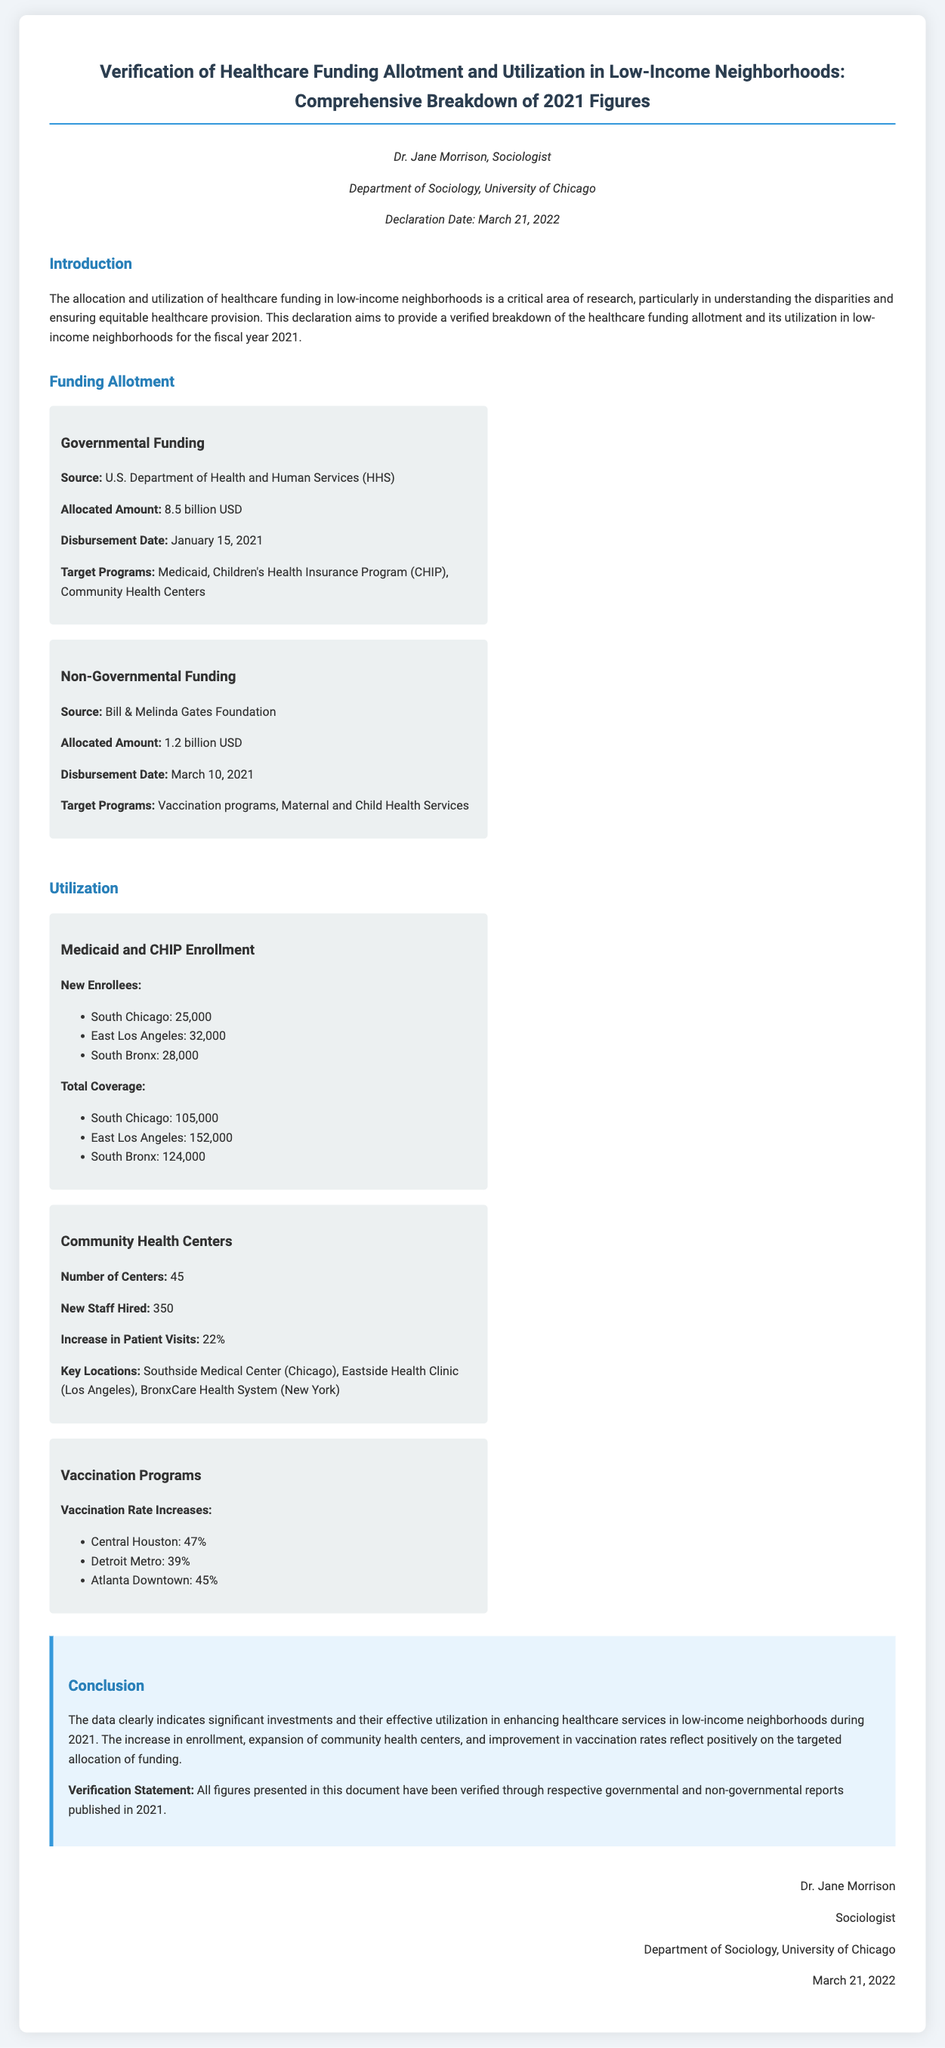What is the allocated amount for governmental funding? The document states the allocated amount for governmental funding, which is provided under the funding allotment section.
Answer: 8.5 billion USD Who is the author of the declaration? The document presents the author information at the beginning, allowing for easy retrieval of the author's identity.
Answer: Dr. Jane Morrison What date was the non-governmental funding disbursed? The disbursement date for non-governmental funding is indicated in the funding allotment section.
Answer: March 10, 2021 What percentage did patient visits increase in community health centers? The percentage increase in patient visits is specifically mentioned in the utilization section under community health centers.
Answer: 22% How many new enrollees were recorded in East Los Angeles for Medicaid and CHIP? The document details the number of new enrollees by neighborhood for Medicaid and CHIP, which is crucial for understanding enrollment metrics.
Answer: 32,000 What is the target program for non-governmental funding? The document explains which programs are targeted by the non-governmental funding in the funding allotment section.
Answer: Vaccination programs, Maternal and Child Health Services In which city is the Southside Medical Center located? The document specifies key locations for community health centers, including the city where Southside Medical Center is located.
Answer: Chicago What was the conclusion regarding healthcare services in low-income neighborhoods in 2021? The conclusion offers insights on the effectiveness of funding and healthcare services in low-income neighborhoods.
Answer: Significant investments and effective utilization How many community health centers were reported in the document? The utilization section provides numerical data regarding the total number of community health centers.
Answer: 45 